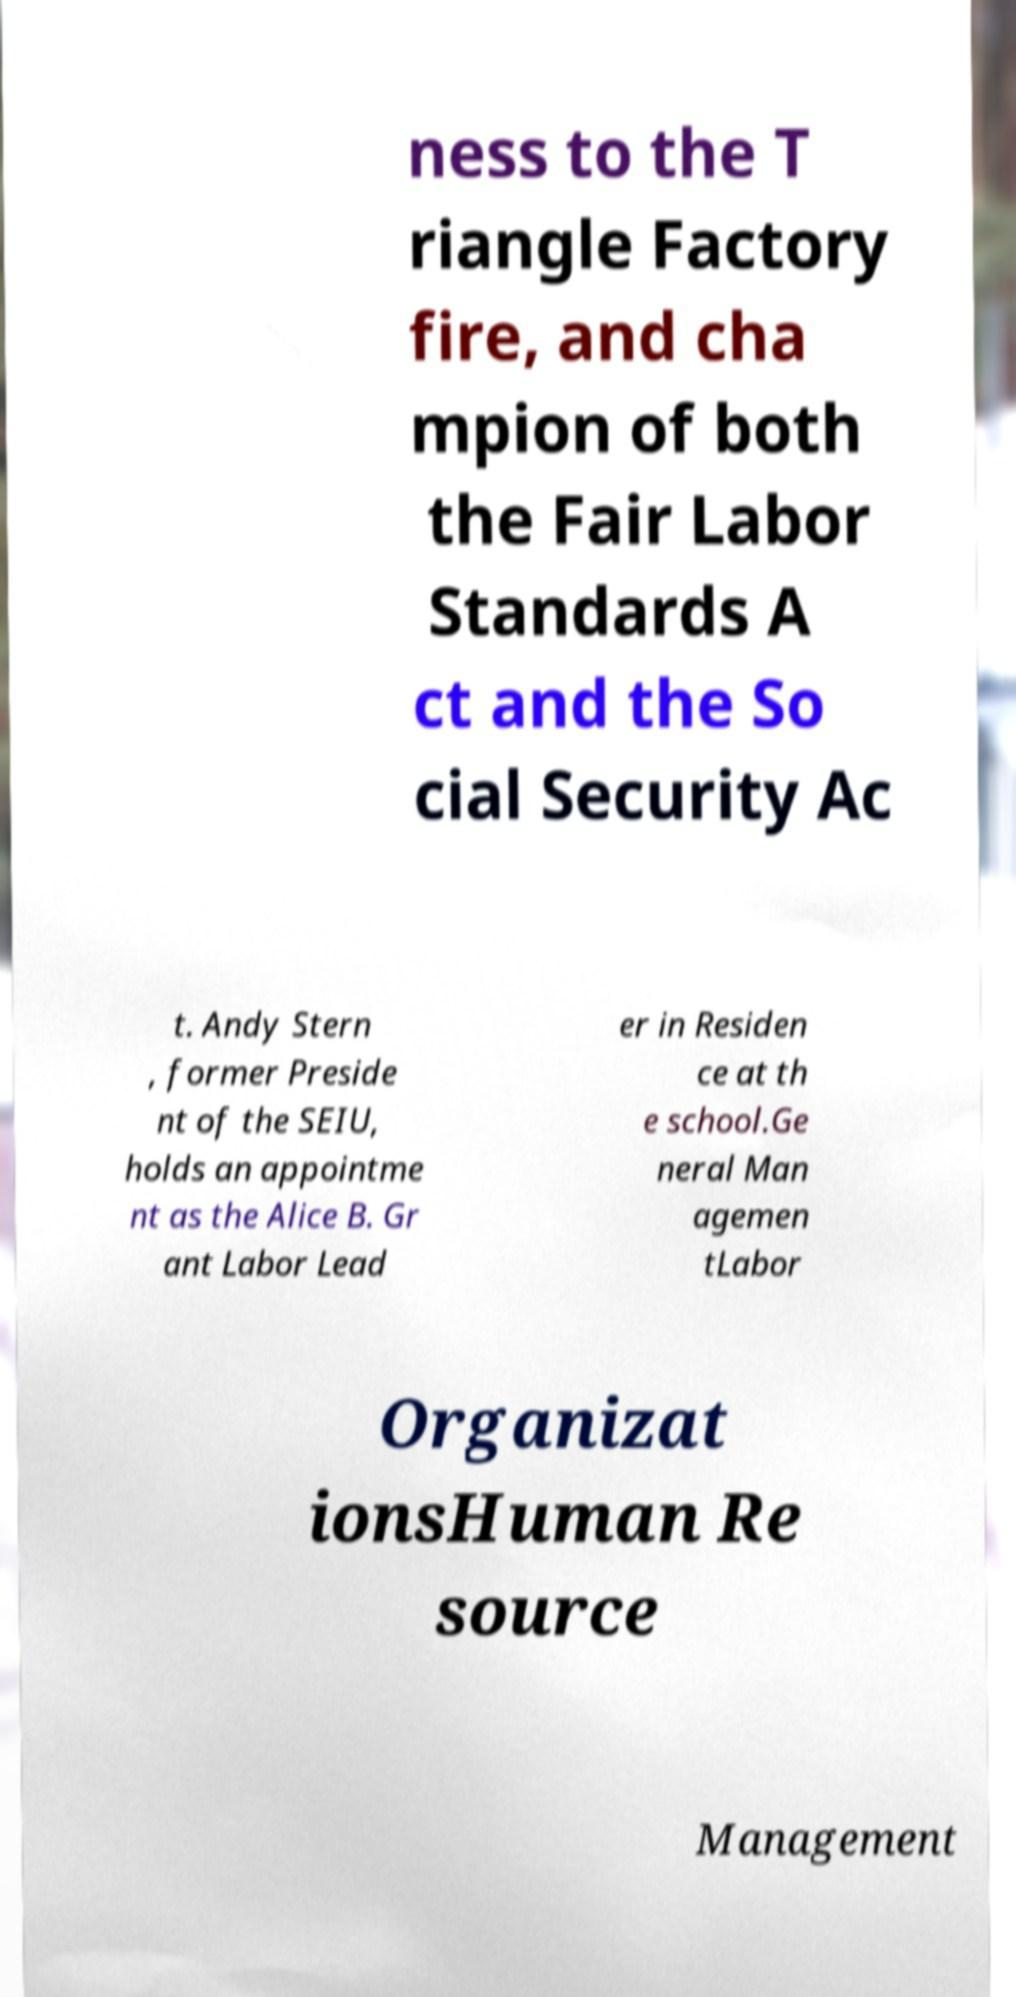I need the written content from this picture converted into text. Can you do that? ness to the T riangle Factory fire, and cha mpion of both the Fair Labor Standards A ct and the So cial Security Ac t. Andy Stern , former Preside nt of the SEIU, holds an appointme nt as the Alice B. Gr ant Labor Lead er in Residen ce at th e school.Ge neral Man agemen tLabor Organizat ionsHuman Re source Management 